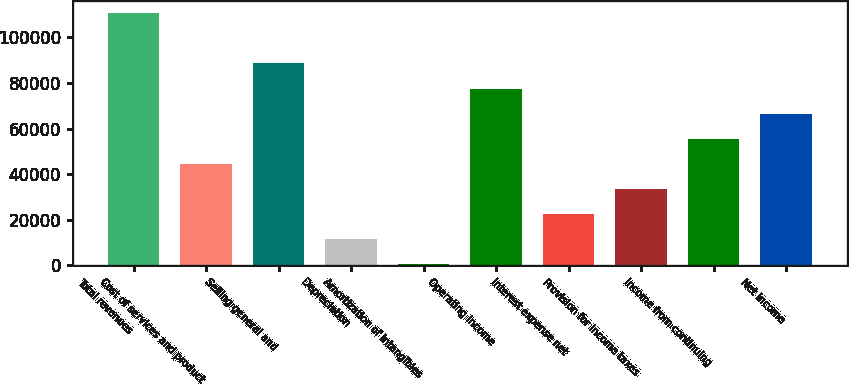<chart> <loc_0><loc_0><loc_500><loc_500><bar_chart><fcel>Total revenues<fcel>Cost of services and product<fcel>Selling general and<fcel>Depreciation<fcel>Amortization of intangibles<fcel>Operating income<fcel>Interest expense net<fcel>Provision for income taxes<fcel>Income from continuing<fcel>Net income<nl><fcel>110590<fcel>44521.6<fcel>88567.2<fcel>11487.4<fcel>476<fcel>77555.8<fcel>22498.8<fcel>33510.2<fcel>55533<fcel>66544.4<nl></chart> 